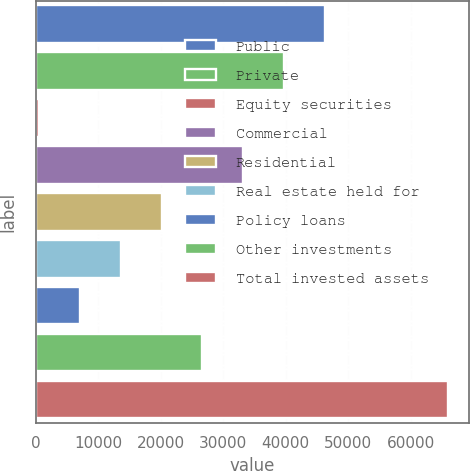Convert chart. <chart><loc_0><loc_0><loc_500><loc_500><bar_chart><fcel>Public<fcel>Private<fcel>Equity securities<fcel>Commercial<fcel>Residential<fcel>Real estate held for<fcel>Policy loans<fcel>Other investments<fcel>Total invested assets<nl><fcel>46330.3<fcel>39781.2<fcel>486.8<fcel>33232.2<fcel>20134<fcel>13584.9<fcel>7035.87<fcel>26683.1<fcel>65977.5<nl></chart> 